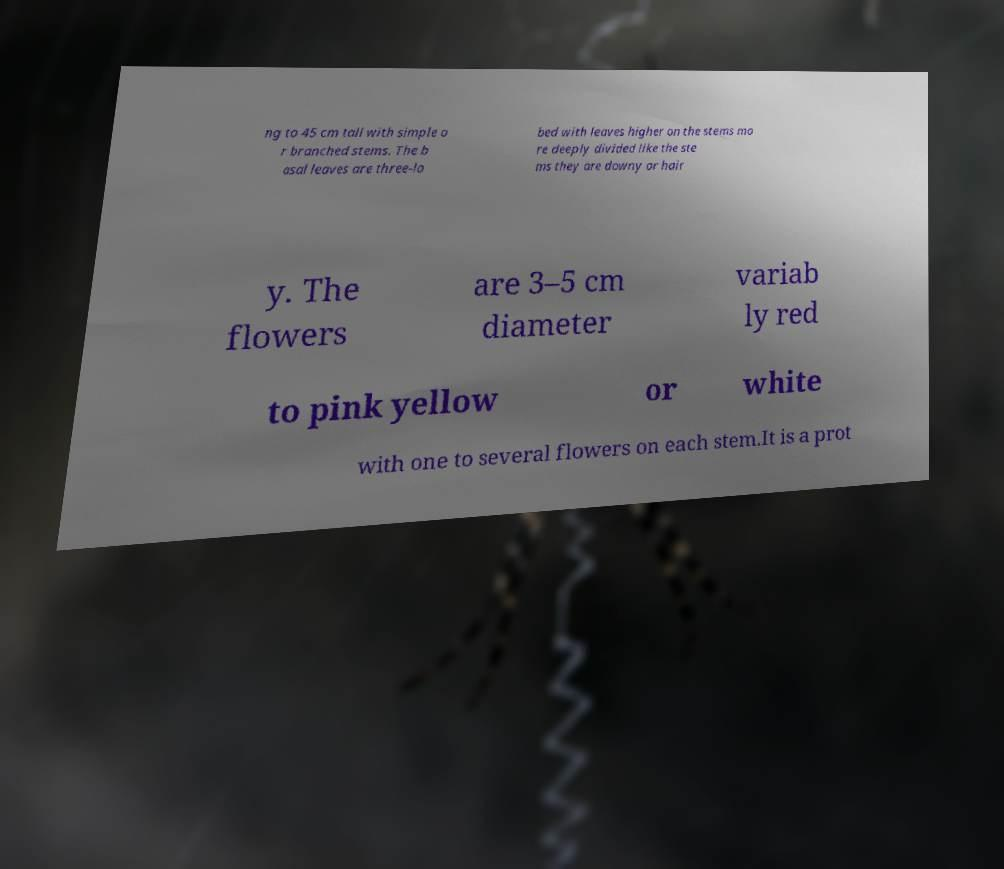Please read and relay the text visible in this image. What does it say? ng to 45 cm tall with simple o r branched stems. The b asal leaves are three-lo bed with leaves higher on the stems mo re deeply divided like the ste ms they are downy or hair y. The flowers are 3–5 cm diameter variab ly red to pink yellow or white with one to several flowers on each stem.It is a prot 